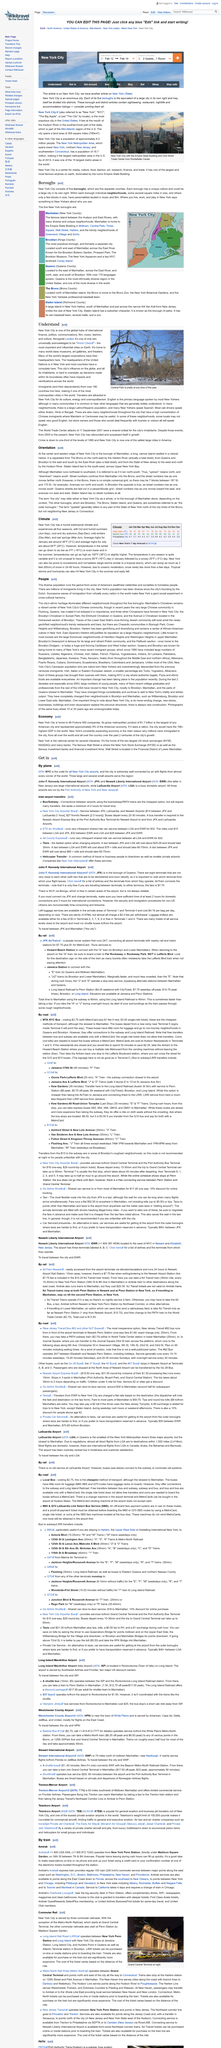Outline some significant characteristics in this image. New York City has a humid subtropical climate, characterized by hot and humid summers, and mild winters with infrequent snowfall. Yes, due to the type of climate, the temperatures in all seasons are variable. The daily high in February, as depicted in the image, was 41 degrees Fahrenheit. 